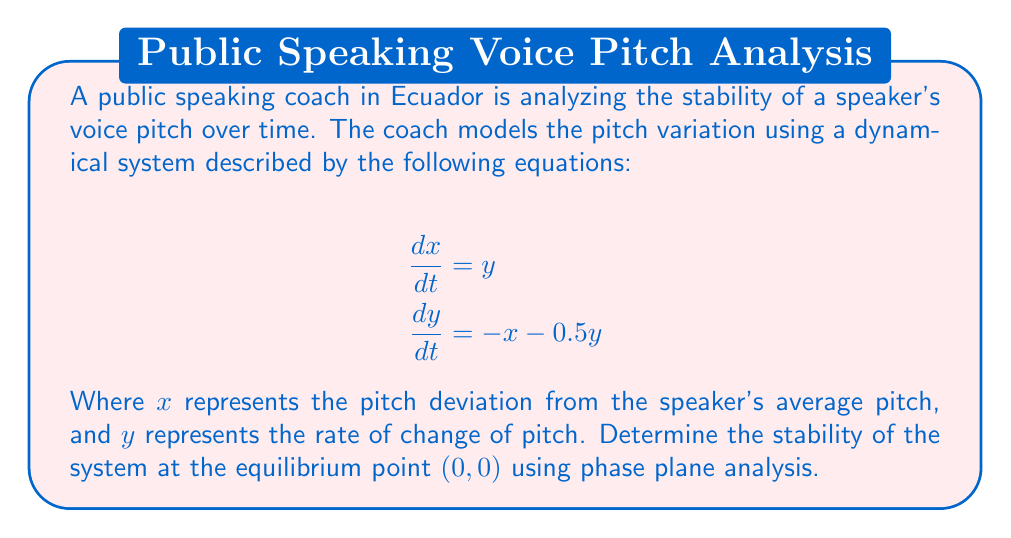Provide a solution to this math problem. To determine the stability of the system at the equilibrium point $(0,0)$, we'll follow these steps:

1. Identify the system:
   The given system is:
   $$\frac{dx}{dt} = y$$
   $$\frac{dy}{dt} = -x - 0.5y$$

2. Find the Jacobian matrix:
   The Jacobian matrix $J$ is:
   $$J = \begin{bmatrix}
   \frac{\partial f_1}{\partial x} & \frac{\partial f_1}{\partial y} \\
   \frac{\partial f_2}{\partial x} & \frac{\partial f_2}{\partial y}
   \end{bmatrix} = \begin{bmatrix}
   0 & 1 \\
   -1 & -0.5
   \end{bmatrix}$$

3. Calculate the eigenvalues:
   The characteristic equation is:
   $$\det(J - \lambda I) = \begin{vmatrix}
   -\lambda & 1 \\
   -1 & -0.5 - \lambda
   \end{vmatrix} = \lambda^2 + 0.5\lambda + 1 = 0$$

   Solving this equation:
   $$\lambda = \frac{-0.5 \pm \sqrt{0.25 - 4}}{2} = \frac{-0.5 \pm \sqrt{-3.75}}{2}$$
   $$\lambda_1 = -0.25 + 0.968i, \lambda_2 = -0.25 - 0.968i$$

4. Analyze the eigenvalues:
   Both eigenvalues have negative real parts and non-zero imaginary parts.

5. Determine stability:
   When both eigenvalues have negative real parts, the equilibrium point is asymptotically stable. The non-zero imaginary parts indicate that the solution will spiral towards the equilibrium point.

6. Interpret the results:
   In the context of voice pitch stability, this means that any deviation from the average pitch (represented by the equilibrium point) will gradually decrease over time, with the pitch oscillating around the average before settling.
Answer: The system is asymptotically stable at $(0,0)$ with spiraling behavior. 